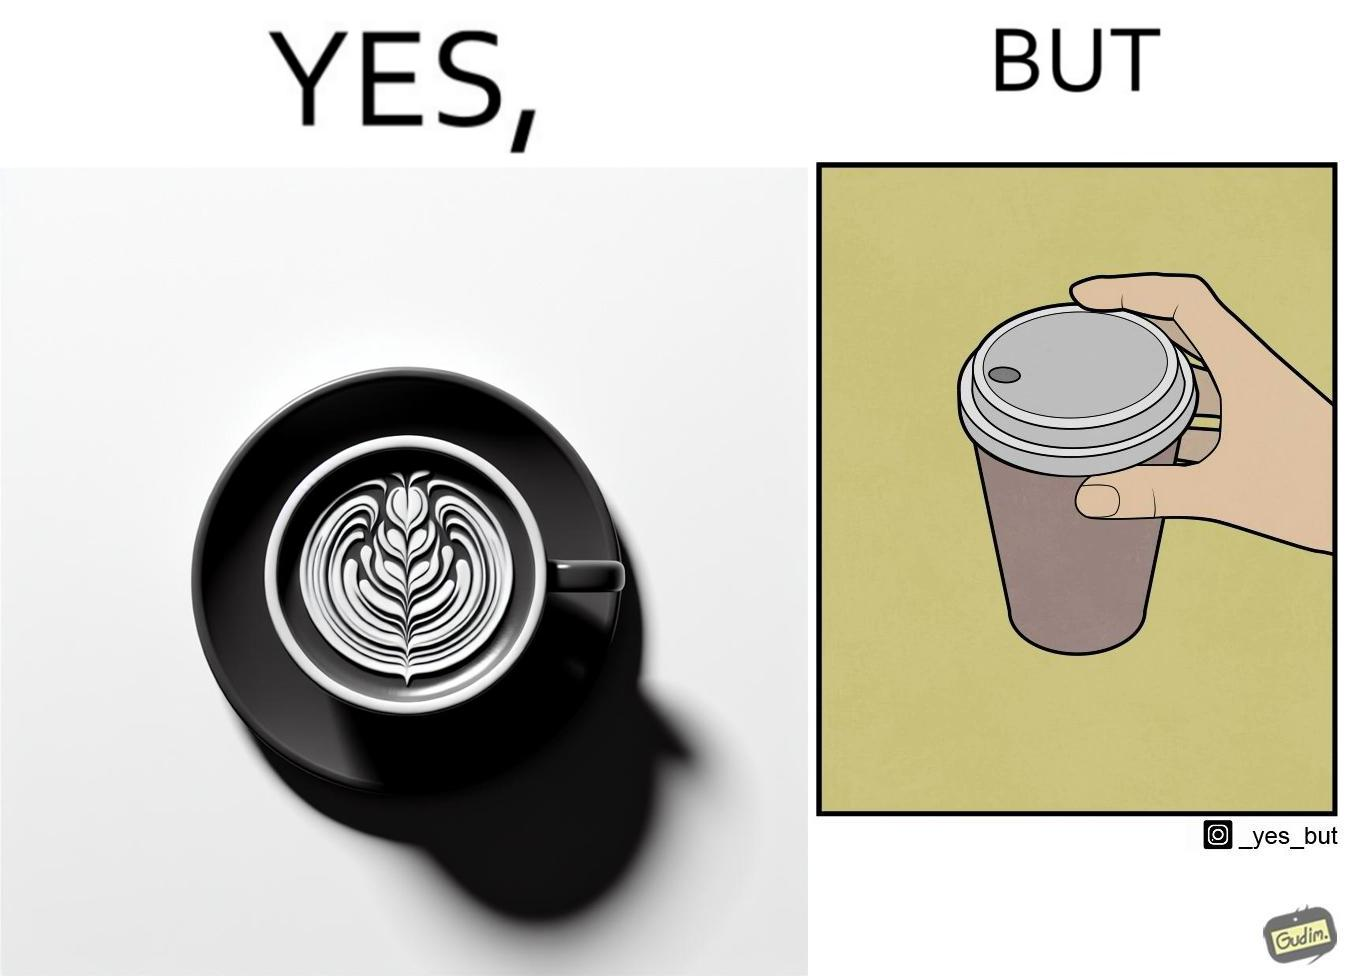What is the satirical meaning behind this image? The images are funny since it shows how someone has put effort into a cup of coffee to do latte art on it only for it to be invisible after a lid is put on the coffee cup before serving to a customer 